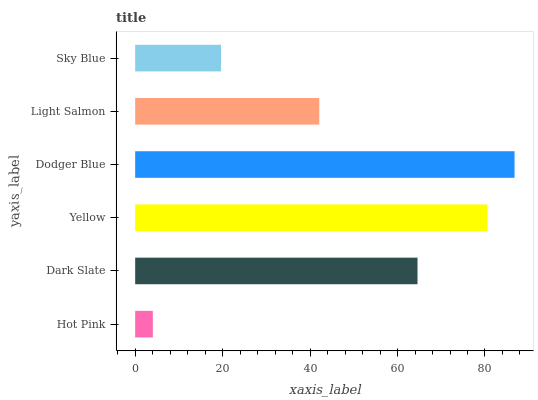Is Hot Pink the minimum?
Answer yes or no. Yes. Is Dodger Blue the maximum?
Answer yes or no. Yes. Is Dark Slate the minimum?
Answer yes or no. No. Is Dark Slate the maximum?
Answer yes or no. No. Is Dark Slate greater than Hot Pink?
Answer yes or no. Yes. Is Hot Pink less than Dark Slate?
Answer yes or no. Yes. Is Hot Pink greater than Dark Slate?
Answer yes or no. No. Is Dark Slate less than Hot Pink?
Answer yes or no. No. Is Dark Slate the high median?
Answer yes or no. Yes. Is Light Salmon the low median?
Answer yes or no. Yes. Is Yellow the high median?
Answer yes or no. No. Is Hot Pink the low median?
Answer yes or no. No. 